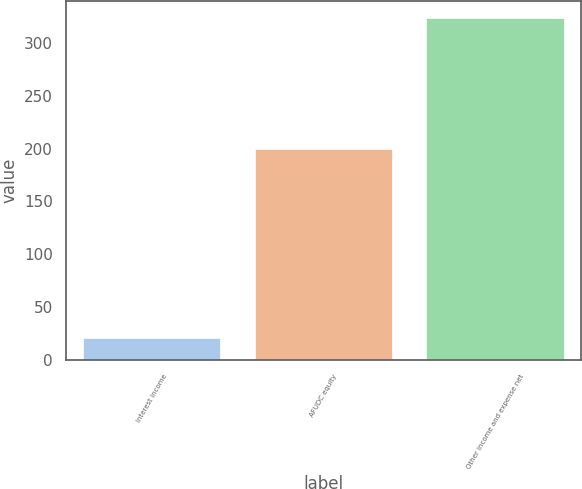<chart> <loc_0><loc_0><loc_500><loc_500><bar_chart><fcel>Interest income<fcel>AFUDC equity<fcel>Other income and expense net<nl><fcel>21<fcel>200<fcel>324<nl></chart> 